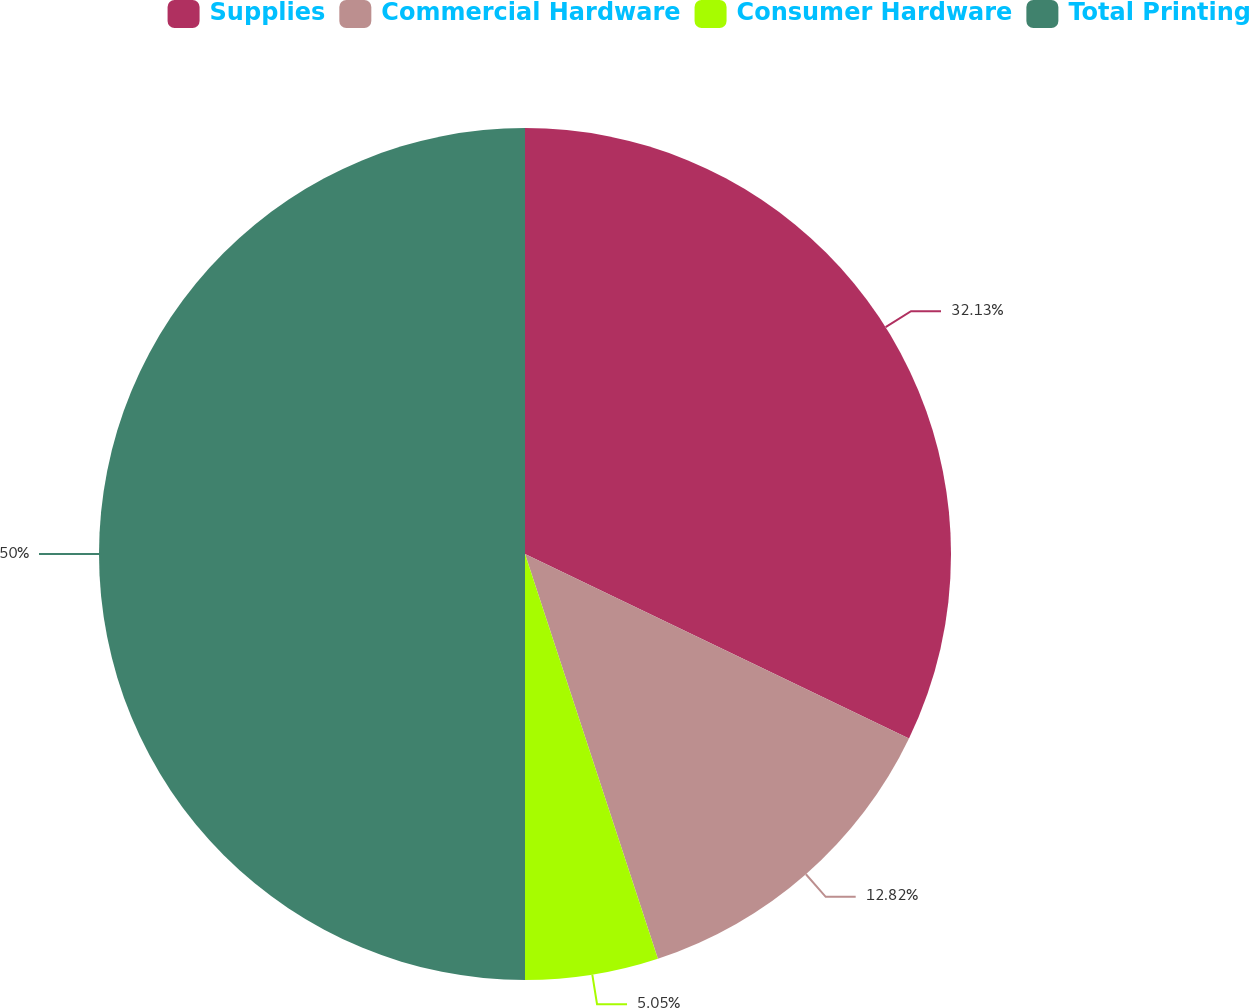<chart> <loc_0><loc_0><loc_500><loc_500><pie_chart><fcel>Supplies<fcel>Commercial Hardware<fcel>Consumer Hardware<fcel>Total Printing<nl><fcel>32.13%<fcel>12.82%<fcel>5.05%<fcel>50.0%<nl></chart> 